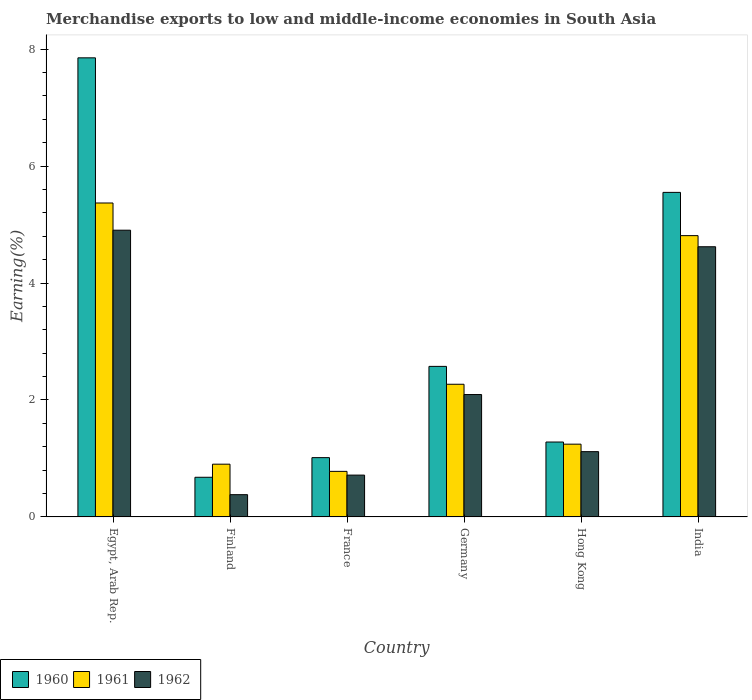How many different coloured bars are there?
Give a very brief answer. 3. How many groups of bars are there?
Provide a short and direct response. 6. Are the number of bars per tick equal to the number of legend labels?
Provide a succinct answer. Yes. Are the number of bars on each tick of the X-axis equal?
Make the answer very short. Yes. How many bars are there on the 2nd tick from the left?
Ensure brevity in your answer.  3. How many bars are there on the 6th tick from the right?
Provide a succinct answer. 3. What is the label of the 5th group of bars from the left?
Make the answer very short. Hong Kong. In how many cases, is the number of bars for a given country not equal to the number of legend labels?
Keep it short and to the point. 0. What is the percentage of amount earned from merchandise exports in 1961 in France?
Offer a terse response. 0.78. Across all countries, what is the maximum percentage of amount earned from merchandise exports in 1962?
Keep it short and to the point. 4.9. Across all countries, what is the minimum percentage of amount earned from merchandise exports in 1960?
Offer a terse response. 0.68. In which country was the percentage of amount earned from merchandise exports in 1962 maximum?
Offer a terse response. Egypt, Arab Rep. In which country was the percentage of amount earned from merchandise exports in 1960 minimum?
Offer a very short reply. Finland. What is the total percentage of amount earned from merchandise exports in 1962 in the graph?
Ensure brevity in your answer.  13.83. What is the difference between the percentage of amount earned from merchandise exports in 1962 in Egypt, Arab Rep. and that in Germany?
Give a very brief answer. 2.81. What is the difference between the percentage of amount earned from merchandise exports in 1960 in Finland and the percentage of amount earned from merchandise exports in 1961 in Hong Kong?
Offer a very short reply. -0.57. What is the average percentage of amount earned from merchandise exports in 1960 per country?
Offer a very short reply. 3.16. What is the difference between the percentage of amount earned from merchandise exports of/in 1960 and percentage of amount earned from merchandise exports of/in 1962 in Finland?
Provide a succinct answer. 0.3. In how many countries, is the percentage of amount earned from merchandise exports in 1960 greater than 7.6 %?
Offer a terse response. 1. What is the ratio of the percentage of amount earned from merchandise exports in 1960 in Egypt, Arab Rep. to that in France?
Offer a very short reply. 7.74. Is the percentage of amount earned from merchandise exports in 1961 in Egypt, Arab Rep. less than that in Finland?
Your response must be concise. No. What is the difference between the highest and the second highest percentage of amount earned from merchandise exports in 1960?
Ensure brevity in your answer.  -2.98. What is the difference between the highest and the lowest percentage of amount earned from merchandise exports in 1962?
Make the answer very short. 4.52. In how many countries, is the percentage of amount earned from merchandise exports in 1961 greater than the average percentage of amount earned from merchandise exports in 1961 taken over all countries?
Your answer should be compact. 2. What does the 3rd bar from the left in Germany represents?
Offer a very short reply. 1962. What does the 3rd bar from the right in Hong Kong represents?
Provide a succinct answer. 1960. Is it the case that in every country, the sum of the percentage of amount earned from merchandise exports in 1960 and percentage of amount earned from merchandise exports in 1962 is greater than the percentage of amount earned from merchandise exports in 1961?
Provide a short and direct response. Yes. How many bars are there?
Make the answer very short. 18. Are the values on the major ticks of Y-axis written in scientific E-notation?
Your answer should be very brief. No. Does the graph contain grids?
Provide a succinct answer. No. Where does the legend appear in the graph?
Provide a succinct answer. Bottom left. How many legend labels are there?
Offer a terse response. 3. What is the title of the graph?
Give a very brief answer. Merchandise exports to low and middle-income economies in South Asia. What is the label or title of the X-axis?
Provide a short and direct response. Country. What is the label or title of the Y-axis?
Your answer should be very brief. Earning(%). What is the Earning(%) in 1960 in Egypt, Arab Rep.?
Your response must be concise. 7.85. What is the Earning(%) in 1961 in Egypt, Arab Rep.?
Your response must be concise. 5.37. What is the Earning(%) of 1962 in Egypt, Arab Rep.?
Provide a succinct answer. 4.9. What is the Earning(%) of 1960 in Finland?
Offer a terse response. 0.68. What is the Earning(%) of 1961 in Finland?
Offer a very short reply. 0.9. What is the Earning(%) of 1962 in Finland?
Provide a short and direct response. 0.38. What is the Earning(%) of 1960 in France?
Offer a very short reply. 1.01. What is the Earning(%) of 1961 in France?
Give a very brief answer. 0.78. What is the Earning(%) in 1962 in France?
Your response must be concise. 0.72. What is the Earning(%) in 1960 in Germany?
Your response must be concise. 2.57. What is the Earning(%) in 1961 in Germany?
Your answer should be very brief. 2.27. What is the Earning(%) of 1962 in Germany?
Make the answer very short. 2.09. What is the Earning(%) of 1960 in Hong Kong?
Your answer should be compact. 1.28. What is the Earning(%) of 1961 in Hong Kong?
Your answer should be compact. 1.24. What is the Earning(%) of 1962 in Hong Kong?
Keep it short and to the point. 1.12. What is the Earning(%) in 1960 in India?
Your answer should be very brief. 5.55. What is the Earning(%) in 1961 in India?
Your answer should be very brief. 4.81. What is the Earning(%) in 1962 in India?
Your response must be concise. 4.62. Across all countries, what is the maximum Earning(%) in 1960?
Offer a very short reply. 7.85. Across all countries, what is the maximum Earning(%) in 1961?
Your response must be concise. 5.37. Across all countries, what is the maximum Earning(%) in 1962?
Give a very brief answer. 4.9. Across all countries, what is the minimum Earning(%) of 1960?
Provide a short and direct response. 0.68. Across all countries, what is the minimum Earning(%) of 1961?
Offer a very short reply. 0.78. Across all countries, what is the minimum Earning(%) of 1962?
Your answer should be very brief. 0.38. What is the total Earning(%) in 1960 in the graph?
Offer a terse response. 18.95. What is the total Earning(%) in 1961 in the graph?
Offer a terse response. 15.37. What is the total Earning(%) of 1962 in the graph?
Give a very brief answer. 13.83. What is the difference between the Earning(%) of 1960 in Egypt, Arab Rep. and that in Finland?
Your answer should be very brief. 7.17. What is the difference between the Earning(%) of 1961 in Egypt, Arab Rep. and that in Finland?
Make the answer very short. 4.47. What is the difference between the Earning(%) of 1962 in Egypt, Arab Rep. and that in Finland?
Your answer should be compact. 4.52. What is the difference between the Earning(%) in 1960 in Egypt, Arab Rep. and that in France?
Your response must be concise. 6.84. What is the difference between the Earning(%) of 1961 in Egypt, Arab Rep. and that in France?
Offer a terse response. 4.59. What is the difference between the Earning(%) of 1962 in Egypt, Arab Rep. and that in France?
Your response must be concise. 4.19. What is the difference between the Earning(%) of 1960 in Egypt, Arab Rep. and that in Germany?
Offer a very short reply. 5.28. What is the difference between the Earning(%) of 1961 in Egypt, Arab Rep. and that in Germany?
Give a very brief answer. 3.1. What is the difference between the Earning(%) in 1962 in Egypt, Arab Rep. and that in Germany?
Give a very brief answer. 2.81. What is the difference between the Earning(%) in 1960 in Egypt, Arab Rep. and that in Hong Kong?
Your answer should be compact. 6.57. What is the difference between the Earning(%) in 1961 in Egypt, Arab Rep. and that in Hong Kong?
Offer a very short reply. 4.12. What is the difference between the Earning(%) in 1962 in Egypt, Arab Rep. and that in Hong Kong?
Ensure brevity in your answer.  3.79. What is the difference between the Earning(%) in 1960 in Egypt, Arab Rep. and that in India?
Your response must be concise. 2.3. What is the difference between the Earning(%) in 1961 in Egypt, Arab Rep. and that in India?
Ensure brevity in your answer.  0.56. What is the difference between the Earning(%) in 1962 in Egypt, Arab Rep. and that in India?
Your answer should be very brief. 0.28. What is the difference between the Earning(%) in 1960 in Finland and that in France?
Ensure brevity in your answer.  -0.34. What is the difference between the Earning(%) in 1961 in Finland and that in France?
Offer a terse response. 0.12. What is the difference between the Earning(%) in 1962 in Finland and that in France?
Ensure brevity in your answer.  -0.33. What is the difference between the Earning(%) of 1960 in Finland and that in Germany?
Provide a succinct answer. -1.9. What is the difference between the Earning(%) of 1961 in Finland and that in Germany?
Make the answer very short. -1.37. What is the difference between the Earning(%) of 1962 in Finland and that in Germany?
Keep it short and to the point. -1.71. What is the difference between the Earning(%) in 1960 in Finland and that in Hong Kong?
Make the answer very short. -0.6. What is the difference between the Earning(%) in 1961 in Finland and that in Hong Kong?
Ensure brevity in your answer.  -0.34. What is the difference between the Earning(%) of 1962 in Finland and that in Hong Kong?
Provide a short and direct response. -0.74. What is the difference between the Earning(%) of 1960 in Finland and that in India?
Ensure brevity in your answer.  -4.87. What is the difference between the Earning(%) in 1961 in Finland and that in India?
Your response must be concise. -3.91. What is the difference between the Earning(%) of 1962 in Finland and that in India?
Ensure brevity in your answer.  -4.24. What is the difference between the Earning(%) of 1960 in France and that in Germany?
Offer a very short reply. -1.56. What is the difference between the Earning(%) of 1961 in France and that in Germany?
Offer a terse response. -1.49. What is the difference between the Earning(%) in 1962 in France and that in Germany?
Offer a terse response. -1.38. What is the difference between the Earning(%) in 1960 in France and that in Hong Kong?
Your answer should be compact. -0.27. What is the difference between the Earning(%) in 1961 in France and that in Hong Kong?
Make the answer very short. -0.47. What is the difference between the Earning(%) of 1962 in France and that in Hong Kong?
Ensure brevity in your answer.  -0.4. What is the difference between the Earning(%) of 1960 in France and that in India?
Keep it short and to the point. -4.54. What is the difference between the Earning(%) in 1961 in France and that in India?
Offer a terse response. -4.03. What is the difference between the Earning(%) of 1962 in France and that in India?
Provide a short and direct response. -3.91. What is the difference between the Earning(%) in 1960 in Germany and that in Hong Kong?
Your answer should be compact. 1.29. What is the difference between the Earning(%) in 1961 in Germany and that in Hong Kong?
Offer a very short reply. 1.02. What is the difference between the Earning(%) of 1962 in Germany and that in Hong Kong?
Make the answer very short. 0.98. What is the difference between the Earning(%) in 1960 in Germany and that in India?
Provide a succinct answer. -2.98. What is the difference between the Earning(%) of 1961 in Germany and that in India?
Your response must be concise. -2.54. What is the difference between the Earning(%) in 1962 in Germany and that in India?
Keep it short and to the point. -2.53. What is the difference between the Earning(%) of 1960 in Hong Kong and that in India?
Offer a very short reply. -4.27. What is the difference between the Earning(%) in 1961 in Hong Kong and that in India?
Give a very brief answer. -3.57. What is the difference between the Earning(%) in 1962 in Hong Kong and that in India?
Give a very brief answer. -3.5. What is the difference between the Earning(%) of 1960 in Egypt, Arab Rep. and the Earning(%) of 1961 in Finland?
Keep it short and to the point. 6.95. What is the difference between the Earning(%) in 1960 in Egypt, Arab Rep. and the Earning(%) in 1962 in Finland?
Provide a short and direct response. 7.47. What is the difference between the Earning(%) of 1961 in Egypt, Arab Rep. and the Earning(%) of 1962 in Finland?
Offer a terse response. 4.99. What is the difference between the Earning(%) in 1960 in Egypt, Arab Rep. and the Earning(%) in 1961 in France?
Your answer should be compact. 7.07. What is the difference between the Earning(%) in 1960 in Egypt, Arab Rep. and the Earning(%) in 1962 in France?
Offer a terse response. 7.14. What is the difference between the Earning(%) of 1961 in Egypt, Arab Rep. and the Earning(%) of 1962 in France?
Your answer should be very brief. 4.65. What is the difference between the Earning(%) of 1960 in Egypt, Arab Rep. and the Earning(%) of 1961 in Germany?
Your answer should be very brief. 5.58. What is the difference between the Earning(%) in 1960 in Egypt, Arab Rep. and the Earning(%) in 1962 in Germany?
Ensure brevity in your answer.  5.76. What is the difference between the Earning(%) of 1961 in Egypt, Arab Rep. and the Earning(%) of 1962 in Germany?
Make the answer very short. 3.28. What is the difference between the Earning(%) of 1960 in Egypt, Arab Rep. and the Earning(%) of 1961 in Hong Kong?
Your response must be concise. 6.61. What is the difference between the Earning(%) of 1960 in Egypt, Arab Rep. and the Earning(%) of 1962 in Hong Kong?
Ensure brevity in your answer.  6.73. What is the difference between the Earning(%) in 1961 in Egypt, Arab Rep. and the Earning(%) in 1962 in Hong Kong?
Your answer should be very brief. 4.25. What is the difference between the Earning(%) of 1960 in Egypt, Arab Rep. and the Earning(%) of 1961 in India?
Your answer should be very brief. 3.04. What is the difference between the Earning(%) in 1960 in Egypt, Arab Rep. and the Earning(%) in 1962 in India?
Offer a very short reply. 3.23. What is the difference between the Earning(%) in 1961 in Egypt, Arab Rep. and the Earning(%) in 1962 in India?
Keep it short and to the point. 0.75. What is the difference between the Earning(%) in 1960 in Finland and the Earning(%) in 1961 in France?
Your answer should be very brief. -0.1. What is the difference between the Earning(%) of 1960 in Finland and the Earning(%) of 1962 in France?
Your response must be concise. -0.04. What is the difference between the Earning(%) in 1961 in Finland and the Earning(%) in 1962 in France?
Offer a very short reply. 0.19. What is the difference between the Earning(%) of 1960 in Finland and the Earning(%) of 1961 in Germany?
Ensure brevity in your answer.  -1.59. What is the difference between the Earning(%) of 1960 in Finland and the Earning(%) of 1962 in Germany?
Provide a short and direct response. -1.41. What is the difference between the Earning(%) of 1961 in Finland and the Earning(%) of 1962 in Germany?
Ensure brevity in your answer.  -1.19. What is the difference between the Earning(%) in 1960 in Finland and the Earning(%) in 1961 in Hong Kong?
Keep it short and to the point. -0.57. What is the difference between the Earning(%) of 1960 in Finland and the Earning(%) of 1962 in Hong Kong?
Offer a terse response. -0.44. What is the difference between the Earning(%) of 1961 in Finland and the Earning(%) of 1962 in Hong Kong?
Your response must be concise. -0.21. What is the difference between the Earning(%) of 1960 in Finland and the Earning(%) of 1961 in India?
Make the answer very short. -4.13. What is the difference between the Earning(%) of 1960 in Finland and the Earning(%) of 1962 in India?
Your answer should be compact. -3.94. What is the difference between the Earning(%) of 1961 in Finland and the Earning(%) of 1962 in India?
Provide a succinct answer. -3.72. What is the difference between the Earning(%) in 1960 in France and the Earning(%) in 1961 in Germany?
Offer a very short reply. -1.25. What is the difference between the Earning(%) of 1960 in France and the Earning(%) of 1962 in Germany?
Give a very brief answer. -1.08. What is the difference between the Earning(%) in 1961 in France and the Earning(%) in 1962 in Germany?
Offer a terse response. -1.31. What is the difference between the Earning(%) in 1960 in France and the Earning(%) in 1961 in Hong Kong?
Your response must be concise. -0.23. What is the difference between the Earning(%) of 1960 in France and the Earning(%) of 1962 in Hong Kong?
Your response must be concise. -0.1. What is the difference between the Earning(%) of 1961 in France and the Earning(%) of 1962 in Hong Kong?
Provide a succinct answer. -0.34. What is the difference between the Earning(%) in 1960 in France and the Earning(%) in 1961 in India?
Your answer should be very brief. -3.8. What is the difference between the Earning(%) of 1960 in France and the Earning(%) of 1962 in India?
Your answer should be compact. -3.61. What is the difference between the Earning(%) in 1961 in France and the Earning(%) in 1962 in India?
Your answer should be compact. -3.84. What is the difference between the Earning(%) in 1960 in Germany and the Earning(%) in 1961 in Hong Kong?
Offer a very short reply. 1.33. What is the difference between the Earning(%) in 1960 in Germany and the Earning(%) in 1962 in Hong Kong?
Your response must be concise. 1.46. What is the difference between the Earning(%) of 1961 in Germany and the Earning(%) of 1962 in Hong Kong?
Your answer should be very brief. 1.15. What is the difference between the Earning(%) in 1960 in Germany and the Earning(%) in 1961 in India?
Provide a succinct answer. -2.24. What is the difference between the Earning(%) in 1960 in Germany and the Earning(%) in 1962 in India?
Offer a very short reply. -2.05. What is the difference between the Earning(%) in 1961 in Germany and the Earning(%) in 1962 in India?
Keep it short and to the point. -2.35. What is the difference between the Earning(%) of 1960 in Hong Kong and the Earning(%) of 1961 in India?
Offer a terse response. -3.53. What is the difference between the Earning(%) in 1960 in Hong Kong and the Earning(%) in 1962 in India?
Offer a very short reply. -3.34. What is the difference between the Earning(%) in 1961 in Hong Kong and the Earning(%) in 1962 in India?
Ensure brevity in your answer.  -3.38. What is the average Earning(%) of 1960 per country?
Provide a short and direct response. 3.16. What is the average Earning(%) in 1961 per country?
Keep it short and to the point. 2.56. What is the average Earning(%) in 1962 per country?
Your answer should be compact. 2.3. What is the difference between the Earning(%) of 1960 and Earning(%) of 1961 in Egypt, Arab Rep.?
Your answer should be compact. 2.48. What is the difference between the Earning(%) in 1960 and Earning(%) in 1962 in Egypt, Arab Rep.?
Your answer should be very brief. 2.95. What is the difference between the Earning(%) in 1961 and Earning(%) in 1962 in Egypt, Arab Rep.?
Provide a short and direct response. 0.47. What is the difference between the Earning(%) in 1960 and Earning(%) in 1961 in Finland?
Your answer should be very brief. -0.22. What is the difference between the Earning(%) in 1960 and Earning(%) in 1962 in Finland?
Provide a succinct answer. 0.3. What is the difference between the Earning(%) in 1961 and Earning(%) in 1962 in Finland?
Offer a terse response. 0.52. What is the difference between the Earning(%) in 1960 and Earning(%) in 1961 in France?
Keep it short and to the point. 0.23. What is the difference between the Earning(%) in 1960 and Earning(%) in 1962 in France?
Your answer should be compact. 0.3. What is the difference between the Earning(%) of 1961 and Earning(%) of 1962 in France?
Ensure brevity in your answer.  0.06. What is the difference between the Earning(%) of 1960 and Earning(%) of 1961 in Germany?
Make the answer very short. 0.31. What is the difference between the Earning(%) of 1960 and Earning(%) of 1962 in Germany?
Provide a succinct answer. 0.48. What is the difference between the Earning(%) of 1961 and Earning(%) of 1962 in Germany?
Give a very brief answer. 0.18. What is the difference between the Earning(%) of 1960 and Earning(%) of 1961 in Hong Kong?
Your answer should be very brief. 0.04. What is the difference between the Earning(%) in 1960 and Earning(%) in 1962 in Hong Kong?
Ensure brevity in your answer.  0.16. What is the difference between the Earning(%) of 1961 and Earning(%) of 1962 in Hong Kong?
Give a very brief answer. 0.13. What is the difference between the Earning(%) in 1960 and Earning(%) in 1961 in India?
Your response must be concise. 0.74. What is the difference between the Earning(%) of 1960 and Earning(%) of 1962 in India?
Your answer should be compact. 0.93. What is the difference between the Earning(%) of 1961 and Earning(%) of 1962 in India?
Offer a terse response. 0.19. What is the ratio of the Earning(%) of 1960 in Egypt, Arab Rep. to that in Finland?
Offer a terse response. 11.58. What is the ratio of the Earning(%) in 1961 in Egypt, Arab Rep. to that in Finland?
Your response must be concise. 5.95. What is the ratio of the Earning(%) of 1962 in Egypt, Arab Rep. to that in Finland?
Give a very brief answer. 12.88. What is the ratio of the Earning(%) in 1960 in Egypt, Arab Rep. to that in France?
Offer a terse response. 7.74. What is the ratio of the Earning(%) of 1961 in Egypt, Arab Rep. to that in France?
Provide a succinct answer. 6.89. What is the ratio of the Earning(%) of 1962 in Egypt, Arab Rep. to that in France?
Provide a succinct answer. 6.85. What is the ratio of the Earning(%) of 1960 in Egypt, Arab Rep. to that in Germany?
Your response must be concise. 3.05. What is the ratio of the Earning(%) in 1961 in Egypt, Arab Rep. to that in Germany?
Make the answer very short. 2.37. What is the ratio of the Earning(%) in 1962 in Egypt, Arab Rep. to that in Germany?
Ensure brevity in your answer.  2.34. What is the ratio of the Earning(%) in 1960 in Egypt, Arab Rep. to that in Hong Kong?
Provide a short and direct response. 6.13. What is the ratio of the Earning(%) in 1961 in Egypt, Arab Rep. to that in Hong Kong?
Make the answer very short. 4.31. What is the ratio of the Earning(%) in 1962 in Egypt, Arab Rep. to that in Hong Kong?
Ensure brevity in your answer.  4.39. What is the ratio of the Earning(%) in 1960 in Egypt, Arab Rep. to that in India?
Your response must be concise. 1.41. What is the ratio of the Earning(%) in 1961 in Egypt, Arab Rep. to that in India?
Give a very brief answer. 1.12. What is the ratio of the Earning(%) of 1962 in Egypt, Arab Rep. to that in India?
Your answer should be compact. 1.06. What is the ratio of the Earning(%) in 1960 in Finland to that in France?
Offer a very short reply. 0.67. What is the ratio of the Earning(%) of 1961 in Finland to that in France?
Provide a succinct answer. 1.16. What is the ratio of the Earning(%) of 1962 in Finland to that in France?
Your answer should be compact. 0.53. What is the ratio of the Earning(%) of 1960 in Finland to that in Germany?
Ensure brevity in your answer.  0.26. What is the ratio of the Earning(%) in 1961 in Finland to that in Germany?
Your answer should be compact. 0.4. What is the ratio of the Earning(%) in 1962 in Finland to that in Germany?
Offer a terse response. 0.18. What is the ratio of the Earning(%) in 1960 in Finland to that in Hong Kong?
Offer a terse response. 0.53. What is the ratio of the Earning(%) of 1961 in Finland to that in Hong Kong?
Make the answer very short. 0.73. What is the ratio of the Earning(%) of 1962 in Finland to that in Hong Kong?
Provide a succinct answer. 0.34. What is the ratio of the Earning(%) of 1960 in Finland to that in India?
Give a very brief answer. 0.12. What is the ratio of the Earning(%) of 1961 in Finland to that in India?
Ensure brevity in your answer.  0.19. What is the ratio of the Earning(%) of 1962 in Finland to that in India?
Offer a terse response. 0.08. What is the ratio of the Earning(%) of 1960 in France to that in Germany?
Offer a very short reply. 0.39. What is the ratio of the Earning(%) of 1961 in France to that in Germany?
Give a very brief answer. 0.34. What is the ratio of the Earning(%) of 1962 in France to that in Germany?
Give a very brief answer. 0.34. What is the ratio of the Earning(%) in 1960 in France to that in Hong Kong?
Provide a succinct answer. 0.79. What is the ratio of the Earning(%) of 1961 in France to that in Hong Kong?
Provide a short and direct response. 0.63. What is the ratio of the Earning(%) in 1962 in France to that in Hong Kong?
Offer a terse response. 0.64. What is the ratio of the Earning(%) of 1960 in France to that in India?
Make the answer very short. 0.18. What is the ratio of the Earning(%) of 1961 in France to that in India?
Offer a very short reply. 0.16. What is the ratio of the Earning(%) of 1962 in France to that in India?
Keep it short and to the point. 0.15. What is the ratio of the Earning(%) in 1960 in Germany to that in Hong Kong?
Provide a succinct answer. 2.01. What is the ratio of the Earning(%) in 1961 in Germany to that in Hong Kong?
Give a very brief answer. 1.82. What is the ratio of the Earning(%) in 1962 in Germany to that in Hong Kong?
Your answer should be very brief. 1.87. What is the ratio of the Earning(%) of 1960 in Germany to that in India?
Provide a short and direct response. 0.46. What is the ratio of the Earning(%) of 1961 in Germany to that in India?
Provide a succinct answer. 0.47. What is the ratio of the Earning(%) of 1962 in Germany to that in India?
Your response must be concise. 0.45. What is the ratio of the Earning(%) of 1960 in Hong Kong to that in India?
Give a very brief answer. 0.23. What is the ratio of the Earning(%) of 1961 in Hong Kong to that in India?
Make the answer very short. 0.26. What is the ratio of the Earning(%) of 1962 in Hong Kong to that in India?
Your answer should be compact. 0.24. What is the difference between the highest and the second highest Earning(%) of 1960?
Offer a terse response. 2.3. What is the difference between the highest and the second highest Earning(%) of 1961?
Your answer should be very brief. 0.56. What is the difference between the highest and the second highest Earning(%) in 1962?
Offer a terse response. 0.28. What is the difference between the highest and the lowest Earning(%) of 1960?
Provide a short and direct response. 7.17. What is the difference between the highest and the lowest Earning(%) in 1961?
Offer a very short reply. 4.59. What is the difference between the highest and the lowest Earning(%) of 1962?
Your answer should be compact. 4.52. 